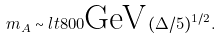<formula> <loc_0><loc_0><loc_500><loc_500>m _ { A } \sim l t 8 0 0 \text {GeV} \, ( \Delta / 5 ) ^ { 1 / 2 } .</formula> 